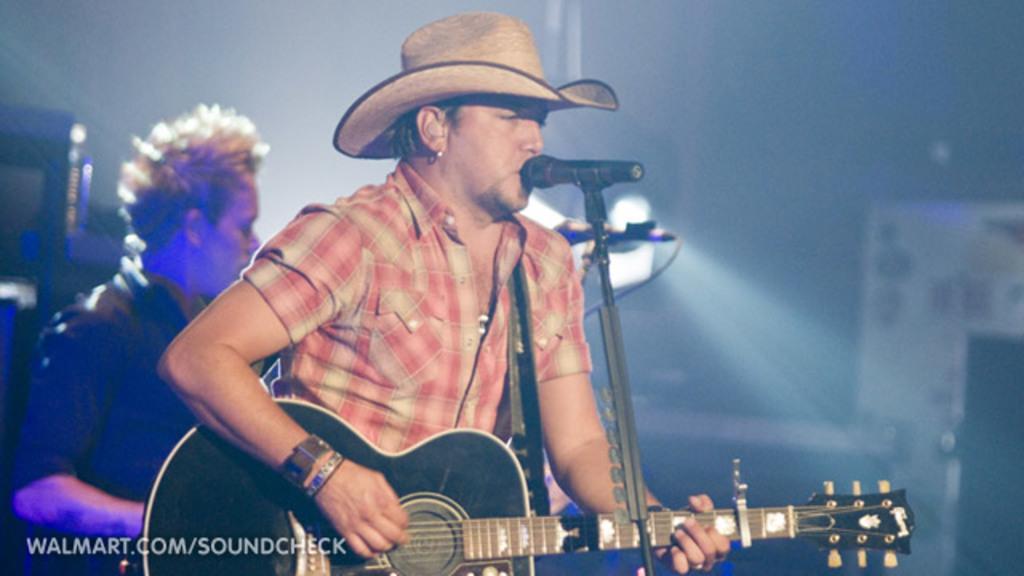Please provide a concise description of this image. This man is standing and playing a guitar in-front of mic. This man wore hat. Backside of this man another man is standing. 